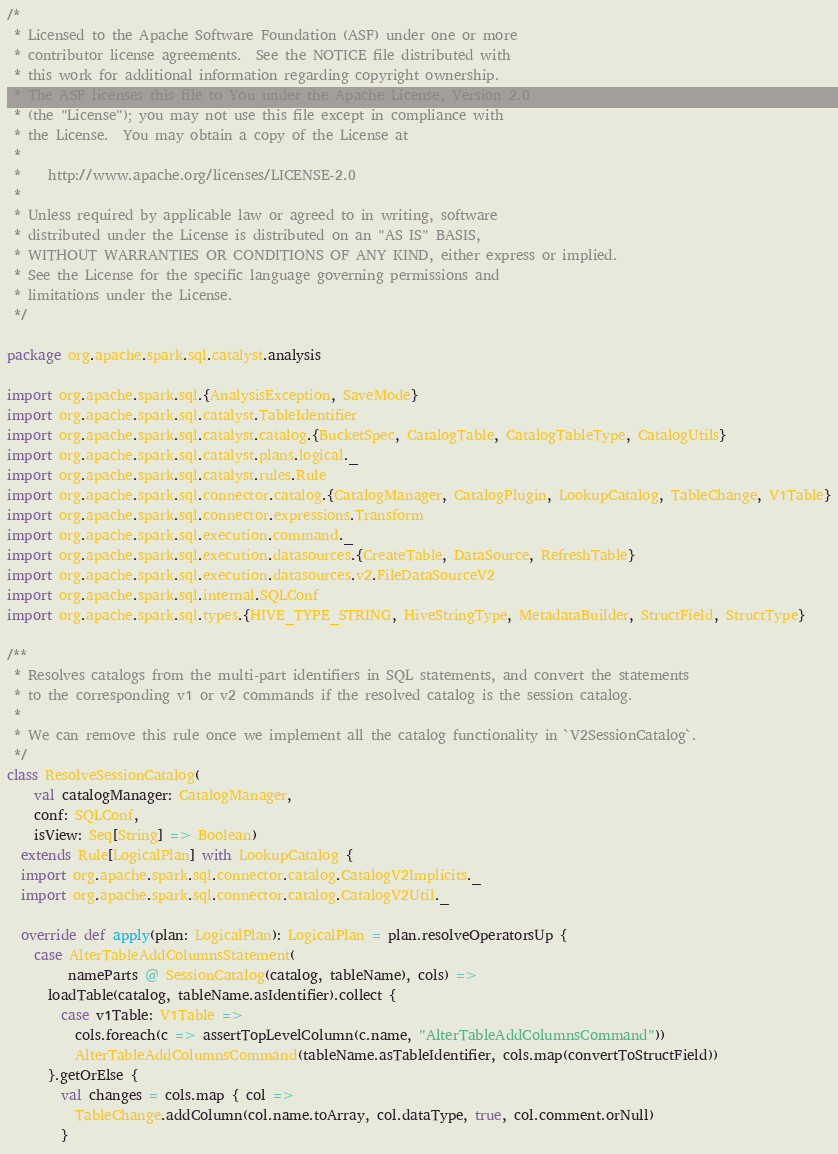Convert code to text. <code><loc_0><loc_0><loc_500><loc_500><_Scala_>/*
 * Licensed to the Apache Software Foundation (ASF) under one or more
 * contributor license agreements.  See the NOTICE file distributed with
 * this work for additional information regarding copyright ownership.
 * The ASF licenses this file to You under the Apache License, Version 2.0
 * (the "License"); you may not use this file except in compliance with
 * the License.  You may obtain a copy of the License at
 *
 *    http://www.apache.org/licenses/LICENSE-2.0
 *
 * Unless required by applicable law or agreed to in writing, software
 * distributed under the License is distributed on an "AS IS" BASIS,
 * WITHOUT WARRANTIES OR CONDITIONS OF ANY KIND, either express or implied.
 * See the License for the specific language governing permissions and
 * limitations under the License.
 */

package org.apache.spark.sql.catalyst.analysis

import org.apache.spark.sql.{AnalysisException, SaveMode}
import org.apache.spark.sql.catalyst.TableIdentifier
import org.apache.spark.sql.catalyst.catalog.{BucketSpec, CatalogTable, CatalogTableType, CatalogUtils}
import org.apache.spark.sql.catalyst.plans.logical._
import org.apache.spark.sql.catalyst.rules.Rule
import org.apache.spark.sql.connector.catalog.{CatalogManager, CatalogPlugin, LookupCatalog, TableChange, V1Table}
import org.apache.spark.sql.connector.expressions.Transform
import org.apache.spark.sql.execution.command._
import org.apache.spark.sql.execution.datasources.{CreateTable, DataSource, RefreshTable}
import org.apache.spark.sql.execution.datasources.v2.FileDataSourceV2
import org.apache.spark.sql.internal.SQLConf
import org.apache.spark.sql.types.{HIVE_TYPE_STRING, HiveStringType, MetadataBuilder, StructField, StructType}

/**
 * Resolves catalogs from the multi-part identifiers in SQL statements, and convert the statements
 * to the corresponding v1 or v2 commands if the resolved catalog is the session catalog.
 *
 * We can remove this rule once we implement all the catalog functionality in `V2SessionCatalog`.
 */
class ResolveSessionCatalog(
    val catalogManager: CatalogManager,
    conf: SQLConf,
    isView: Seq[String] => Boolean)
  extends Rule[LogicalPlan] with LookupCatalog {
  import org.apache.spark.sql.connector.catalog.CatalogV2Implicits._
  import org.apache.spark.sql.connector.catalog.CatalogV2Util._

  override def apply(plan: LogicalPlan): LogicalPlan = plan.resolveOperatorsUp {
    case AlterTableAddColumnsStatement(
         nameParts @ SessionCatalog(catalog, tableName), cols) =>
      loadTable(catalog, tableName.asIdentifier).collect {
        case v1Table: V1Table =>
          cols.foreach(c => assertTopLevelColumn(c.name, "AlterTableAddColumnsCommand"))
          AlterTableAddColumnsCommand(tableName.asTableIdentifier, cols.map(convertToStructField))
      }.getOrElse {
        val changes = cols.map { col =>
          TableChange.addColumn(col.name.toArray, col.dataType, true, col.comment.orNull)
        }</code> 